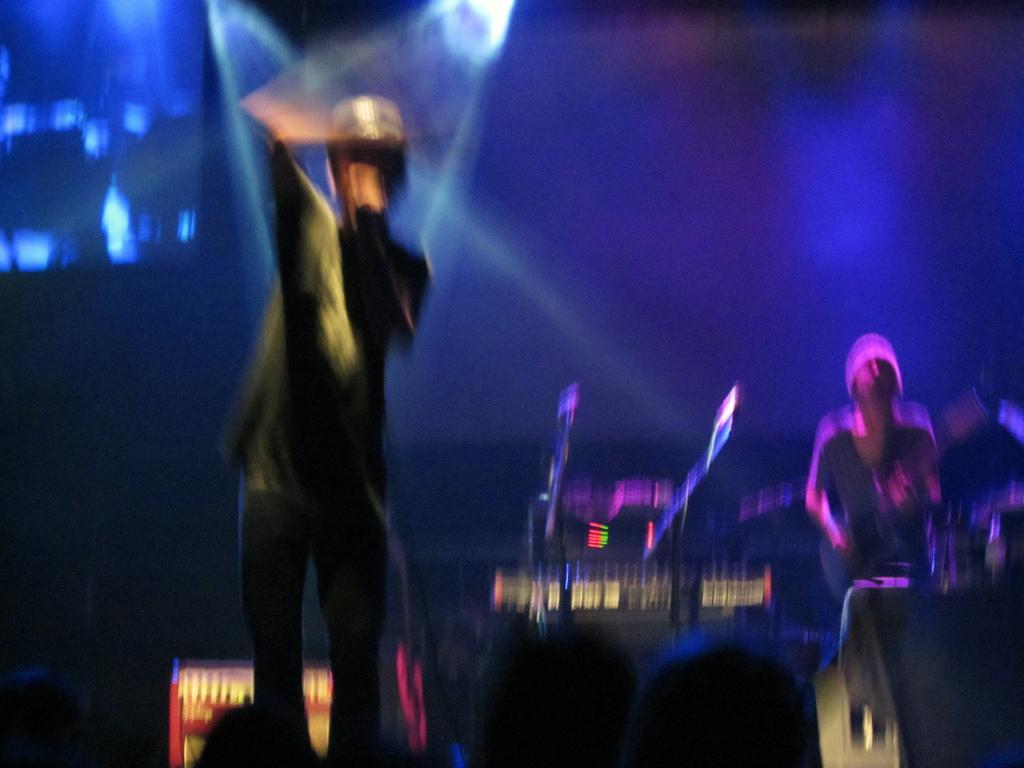How would you summarize this image in a sentence or two? It is a blurry image. In this image I can see people, focusing light and objects. 